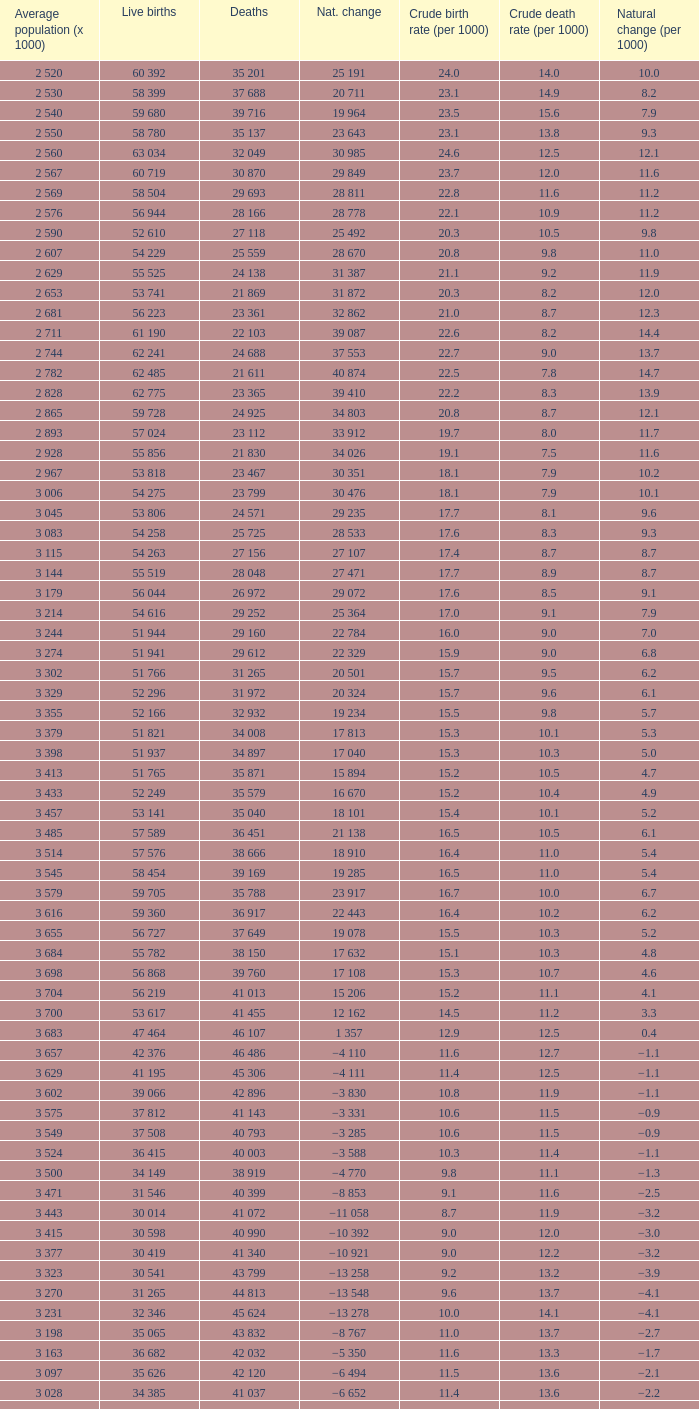Which Average population (x 1000) has a Crude death rate (per 1000) smaller than 10.9, and a Crude birth rate (per 1000) smaller than 19.7, and a Natural change (per 1000) of 8.7, and Live births of 54 263? 3 115. 